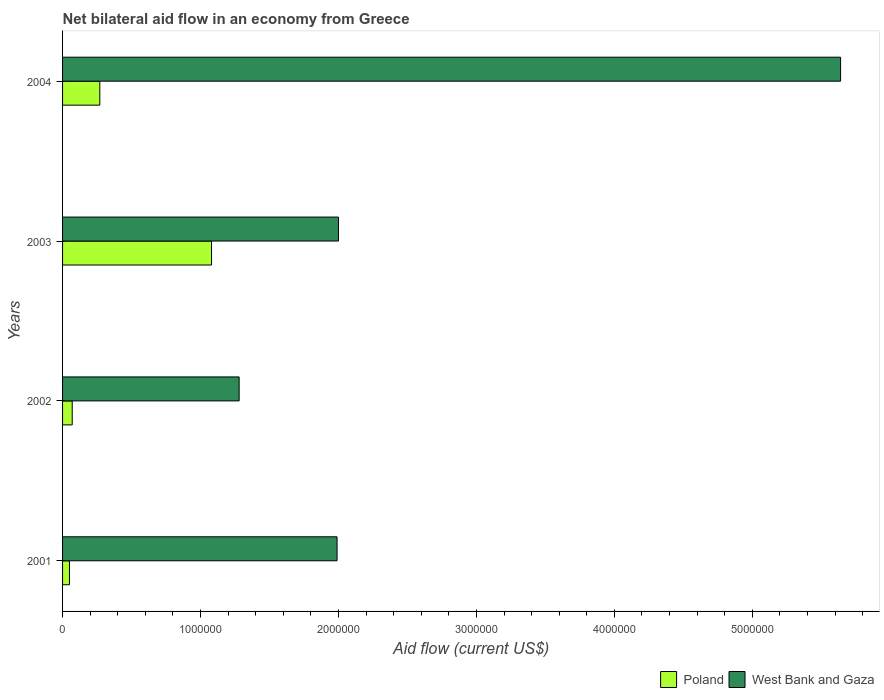Are the number of bars per tick equal to the number of legend labels?
Your response must be concise. Yes. How many bars are there on the 3rd tick from the top?
Keep it short and to the point. 2. What is the label of the 3rd group of bars from the top?
Your answer should be very brief. 2002. What is the net bilateral aid flow in Poland in 2003?
Provide a short and direct response. 1.08e+06. Across all years, what is the maximum net bilateral aid flow in Poland?
Keep it short and to the point. 1.08e+06. Across all years, what is the minimum net bilateral aid flow in Poland?
Your answer should be compact. 5.00e+04. What is the total net bilateral aid flow in Poland in the graph?
Your answer should be compact. 1.47e+06. What is the difference between the net bilateral aid flow in West Bank and Gaza in 2004 and the net bilateral aid flow in Poland in 2001?
Offer a very short reply. 5.59e+06. What is the average net bilateral aid flow in West Bank and Gaza per year?
Give a very brief answer. 2.73e+06. In the year 2002, what is the difference between the net bilateral aid flow in Poland and net bilateral aid flow in West Bank and Gaza?
Ensure brevity in your answer.  -1.21e+06. What is the ratio of the net bilateral aid flow in Poland in 2002 to that in 2004?
Offer a very short reply. 0.26. What is the difference between the highest and the second highest net bilateral aid flow in Poland?
Offer a very short reply. 8.10e+05. What is the difference between the highest and the lowest net bilateral aid flow in West Bank and Gaza?
Keep it short and to the point. 4.36e+06. What does the 1st bar from the top in 2004 represents?
Make the answer very short. West Bank and Gaza. What does the 2nd bar from the bottom in 2003 represents?
Ensure brevity in your answer.  West Bank and Gaza. How many years are there in the graph?
Ensure brevity in your answer.  4. Are the values on the major ticks of X-axis written in scientific E-notation?
Your answer should be very brief. No. Does the graph contain any zero values?
Offer a terse response. No. Does the graph contain grids?
Offer a very short reply. No. How are the legend labels stacked?
Your answer should be compact. Horizontal. What is the title of the graph?
Make the answer very short. Net bilateral aid flow in an economy from Greece. Does "Czech Republic" appear as one of the legend labels in the graph?
Offer a very short reply. No. What is the label or title of the X-axis?
Offer a terse response. Aid flow (current US$). What is the label or title of the Y-axis?
Ensure brevity in your answer.  Years. What is the Aid flow (current US$) in Poland in 2001?
Offer a terse response. 5.00e+04. What is the Aid flow (current US$) in West Bank and Gaza in 2001?
Your response must be concise. 1.99e+06. What is the Aid flow (current US$) of West Bank and Gaza in 2002?
Provide a succinct answer. 1.28e+06. What is the Aid flow (current US$) of Poland in 2003?
Your answer should be compact. 1.08e+06. What is the Aid flow (current US$) of West Bank and Gaza in 2003?
Make the answer very short. 2.00e+06. What is the Aid flow (current US$) in Poland in 2004?
Provide a succinct answer. 2.70e+05. What is the Aid flow (current US$) of West Bank and Gaza in 2004?
Ensure brevity in your answer.  5.64e+06. Across all years, what is the maximum Aid flow (current US$) of Poland?
Provide a short and direct response. 1.08e+06. Across all years, what is the maximum Aid flow (current US$) in West Bank and Gaza?
Give a very brief answer. 5.64e+06. Across all years, what is the minimum Aid flow (current US$) of West Bank and Gaza?
Ensure brevity in your answer.  1.28e+06. What is the total Aid flow (current US$) in Poland in the graph?
Your answer should be compact. 1.47e+06. What is the total Aid flow (current US$) in West Bank and Gaza in the graph?
Give a very brief answer. 1.09e+07. What is the difference between the Aid flow (current US$) in West Bank and Gaza in 2001 and that in 2002?
Make the answer very short. 7.10e+05. What is the difference between the Aid flow (current US$) in Poland in 2001 and that in 2003?
Give a very brief answer. -1.03e+06. What is the difference between the Aid flow (current US$) of West Bank and Gaza in 2001 and that in 2003?
Your answer should be very brief. -10000. What is the difference between the Aid flow (current US$) of Poland in 2001 and that in 2004?
Keep it short and to the point. -2.20e+05. What is the difference between the Aid flow (current US$) in West Bank and Gaza in 2001 and that in 2004?
Your answer should be very brief. -3.65e+06. What is the difference between the Aid flow (current US$) of Poland in 2002 and that in 2003?
Ensure brevity in your answer.  -1.01e+06. What is the difference between the Aid flow (current US$) of West Bank and Gaza in 2002 and that in 2003?
Provide a short and direct response. -7.20e+05. What is the difference between the Aid flow (current US$) in Poland in 2002 and that in 2004?
Make the answer very short. -2.00e+05. What is the difference between the Aid flow (current US$) of West Bank and Gaza in 2002 and that in 2004?
Make the answer very short. -4.36e+06. What is the difference between the Aid flow (current US$) of Poland in 2003 and that in 2004?
Ensure brevity in your answer.  8.10e+05. What is the difference between the Aid flow (current US$) in West Bank and Gaza in 2003 and that in 2004?
Provide a short and direct response. -3.64e+06. What is the difference between the Aid flow (current US$) of Poland in 2001 and the Aid flow (current US$) of West Bank and Gaza in 2002?
Make the answer very short. -1.23e+06. What is the difference between the Aid flow (current US$) of Poland in 2001 and the Aid flow (current US$) of West Bank and Gaza in 2003?
Ensure brevity in your answer.  -1.95e+06. What is the difference between the Aid flow (current US$) in Poland in 2001 and the Aid flow (current US$) in West Bank and Gaza in 2004?
Your answer should be compact. -5.59e+06. What is the difference between the Aid flow (current US$) of Poland in 2002 and the Aid flow (current US$) of West Bank and Gaza in 2003?
Your answer should be very brief. -1.93e+06. What is the difference between the Aid flow (current US$) of Poland in 2002 and the Aid flow (current US$) of West Bank and Gaza in 2004?
Offer a very short reply. -5.57e+06. What is the difference between the Aid flow (current US$) of Poland in 2003 and the Aid flow (current US$) of West Bank and Gaza in 2004?
Provide a short and direct response. -4.56e+06. What is the average Aid flow (current US$) of Poland per year?
Provide a short and direct response. 3.68e+05. What is the average Aid flow (current US$) of West Bank and Gaza per year?
Give a very brief answer. 2.73e+06. In the year 2001, what is the difference between the Aid flow (current US$) in Poland and Aid flow (current US$) in West Bank and Gaza?
Your response must be concise. -1.94e+06. In the year 2002, what is the difference between the Aid flow (current US$) in Poland and Aid flow (current US$) in West Bank and Gaza?
Your response must be concise. -1.21e+06. In the year 2003, what is the difference between the Aid flow (current US$) of Poland and Aid flow (current US$) of West Bank and Gaza?
Offer a terse response. -9.20e+05. In the year 2004, what is the difference between the Aid flow (current US$) in Poland and Aid flow (current US$) in West Bank and Gaza?
Keep it short and to the point. -5.37e+06. What is the ratio of the Aid flow (current US$) of West Bank and Gaza in 2001 to that in 2002?
Provide a succinct answer. 1.55. What is the ratio of the Aid flow (current US$) in Poland in 2001 to that in 2003?
Keep it short and to the point. 0.05. What is the ratio of the Aid flow (current US$) in Poland in 2001 to that in 2004?
Give a very brief answer. 0.19. What is the ratio of the Aid flow (current US$) of West Bank and Gaza in 2001 to that in 2004?
Give a very brief answer. 0.35. What is the ratio of the Aid flow (current US$) of Poland in 2002 to that in 2003?
Make the answer very short. 0.06. What is the ratio of the Aid flow (current US$) in West Bank and Gaza in 2002 to that in 2003?
Make the answer very short. 0.64. What is the ratio of the Aid flow (current US$) of Poland in 2002 to that in 2004?
Your answer should be very brief. 0.26. What is the ratio of the Aid flow (current US$) of West Bank and Gaza in 2002 to that in 2004?
Your answer should be very brief. 0.23. What is the ratio of the Aid flow (current US$) in West Bank and Gaza in 2003 to that in 2004?
Give a very brief answer. 0.35. What is the difference between the highest and the second highest Aid flow (current US$) of Poland?
Provide a short and direct response. 8.10e+05. What is the difference between the highest and the second highest Aid flow (current US$) in West Bank and Gaza?
Ensure brevity in your answer.  3.64e+06. What is the difference between the highest and the lowest Aid flow (current US$) of Poland?
Provide a short and direct response. 1.03e+06. What is the difference between the highest and the lowest Aid flow (current US$) in West Bank and Gaza?
Provide a succinct answer. 4.36e+06. 